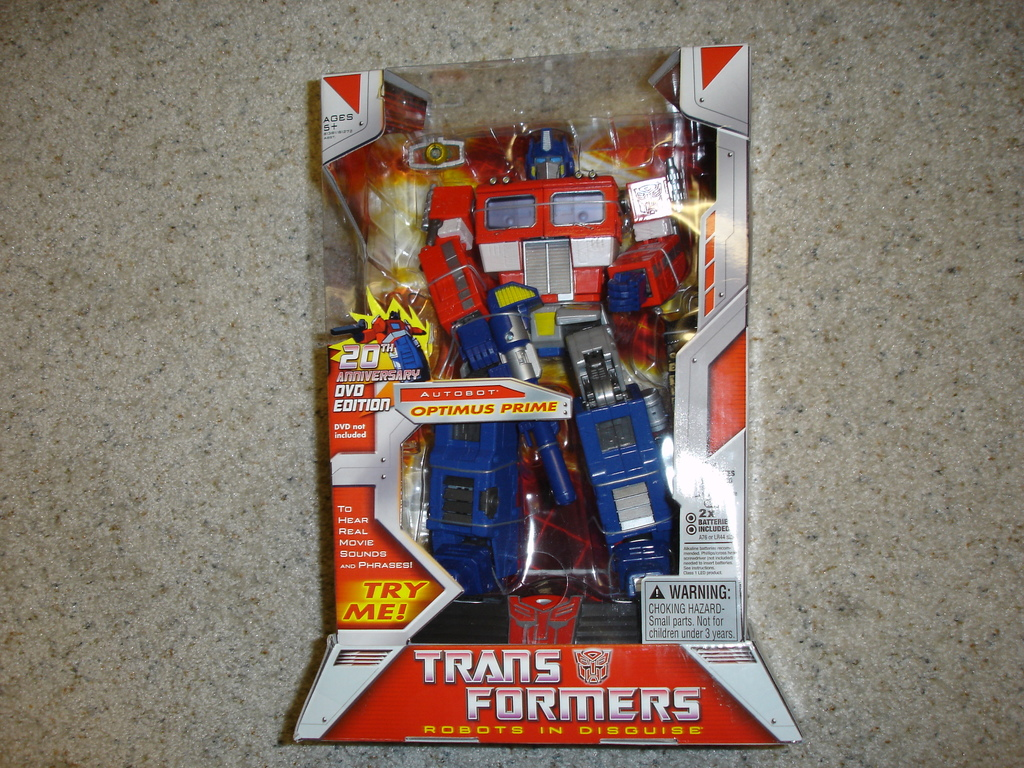What is the significance of including a 'Try Me!' feature on this toy? The 'Try Me!' feature on this toy is significant as it allows potential buyers or children to experience a core aspect of the toy's functionality - its sound effects and phrases - directly through the packaging. This interactive element can enhance the engagement and allure of the toy, making it more appealing in a retail environment. 